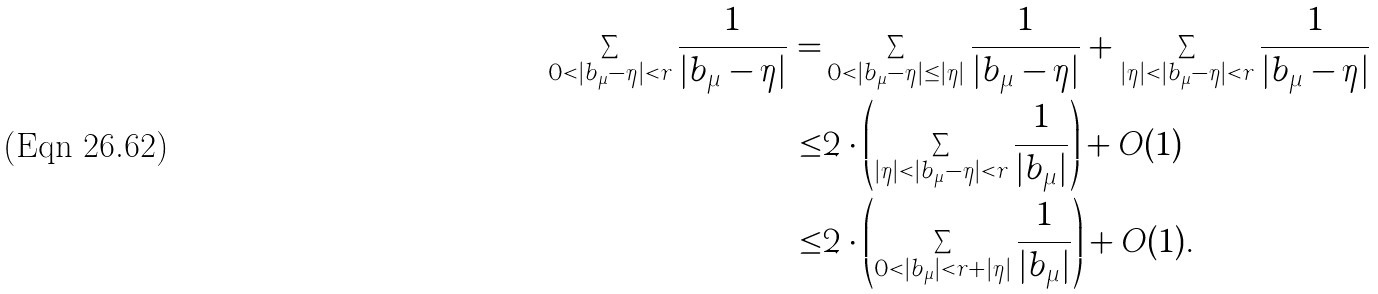Convert formula to latex. <formula><loc_0><loc_0><loc_500><loc_500>\sum _ { 0 < | b _ { \mu } - \eta | < r } \frac { 1 } { | b _ { \mu } - \eta | } = & \sum _ { 0 < | b _ { \mu } - \eta | \leq | \eta | } \frac { 1 } { | b _ { \mu } - \eta | } + \sum _ { | \eta | < | b _ { \mu } - \eta | < r } \frac { 1 } { | b _ { \mu } - \eta | } \\ \leq & 2 \cdot \left ( \sum _ { | \eta | < | b _ { \mu } - \eta | < r } \frac { 1 } { | b _ { \mu } | } \right ) + O ( 1 ) \\ \leq & 2 \cdot \left ( \sum _ { 0 < | b _ { \mu } | < r + | \eta | } \frac { 1 } { | b _ { \mu } | } \right ) + O ( 1 ) .</formula> 